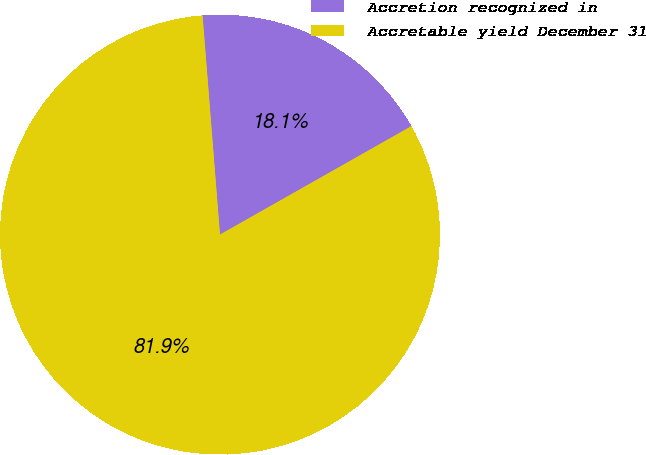<chart> <loc_0><loc_0><loc_500><loc_500><pie_chart><fcel>Accretion recognized in<fcel>Accretable yield December 31<nl><fcel>18.06%<fcel>81.94%<nl></chart> 